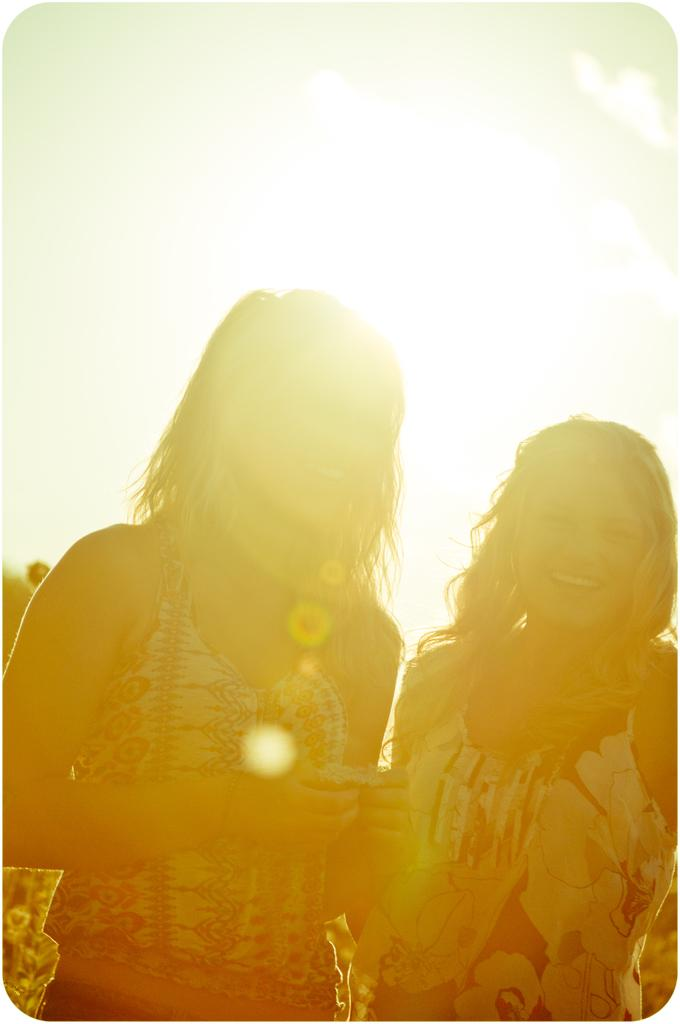How many people are present in the image? There are two women standing in the image. What is the lighting condition in the image? There is sunlight in the background of the image. What shape is the banana that the women are holding in the image? There is no banana present in the image, so it cannot be determined what shape it might have. 